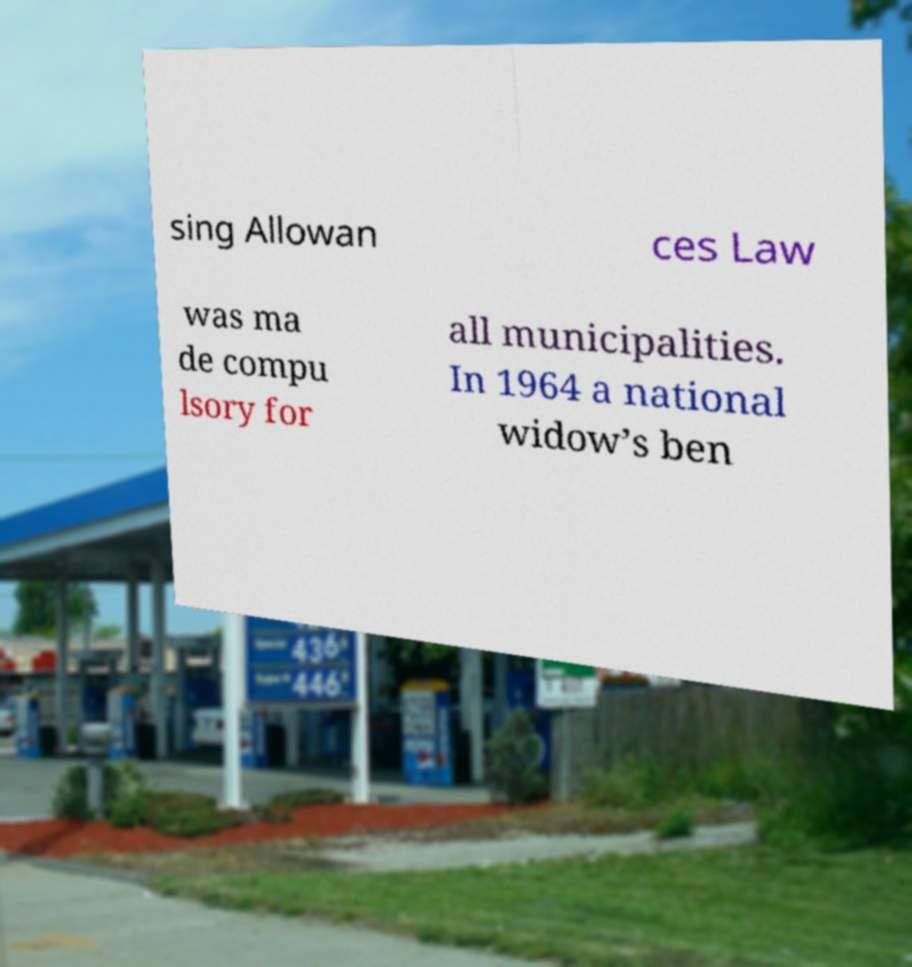I need the written content from this picture converted into text. Can you do that? sing Allowan ces Law was ma de compu lsory for all municipalities. In 1964 a national widow’s ben 